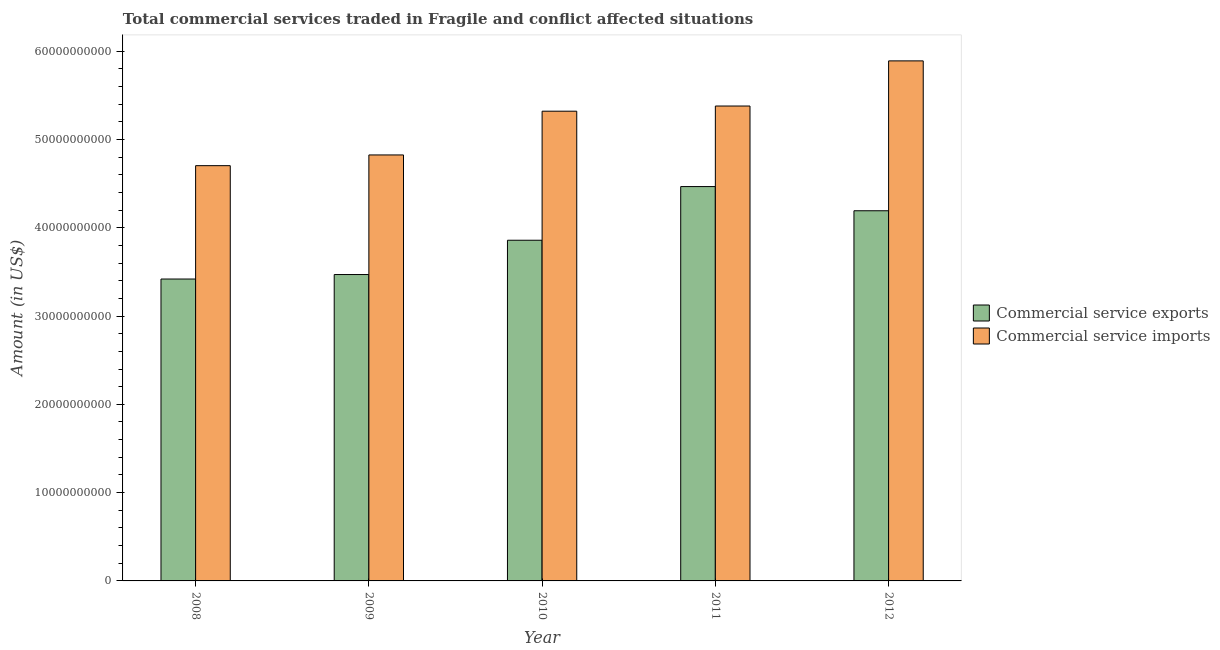How many different coloured bars are there?
Provide a succinct answer. 2. How many groups of bars are there?
Offer a terse response. 5. Are the number of bars per tick equal to the number of legend labels?
Offer a very short reply. Yes. Are the number of bars on each tick of the X-axis equal?
Keep it short and to the point. Yes. How many bars are there on the 3rd tick from the left?
Provide a short and direct response. 2. What is the label of the 3rd group of bars from the left?
Keep it short and to the point. 2010. What is the amount of commercial service exports in 2011?
Provide a succinct answer. 4.47e+1. Across all years, what is the maximum amount of commercial service imports?
Your answer should be compact. 5.89e+1. Across all years, what is the minimum amount of commercial service imports?
Provide a short and direct response. 4.70e+1. What is the total amount of commercial service imports in the graph?
Your answer should be compact. 2.61e+11. What is the difference between the amount of commercial service exports in 2010 and that in 2011?
Ensure brevity in your answer.  -6.08e+09. What is the difference between the amount of commercial service exports in 2012 and the amount of commercial service imports in 2008?
Your response must be concise. 7.73e+09. What is the average amount of commercial service imports per year?
Your response must be concise. 5.22e+1. What is the ratio of the amount of commercial service imports in 2011 to that in 2012?
Offer a terse response. 0.91. Is the difference between the amount of commercial service exports in 2009 and 2011 greater than the difference between the amount of commercial service imports in 2009 and 2011?
Make the answer very short. No. What is the difference between the highest and the second highest amount of commercial service imports?
Provide a succinct answer. 5.11e+09. What is the difference between the highest and the lowest amount of commercial service exports?
Offer a terse response. 1.05e+1. In how many years, is the amount of commercial service imports greater than the average amount of commercial service imports taken over all years?
Your answer should be compact. 3. Is the sum of the amount of commercial service exports in 2009 and 2012 greater than the maximum amount of commercial service imports across all years?
Your response must be concise. Yes. What does the 1st bar from the left in 2008 represents?
Your answer should be very brief. Commercial service exports. What does the 2nd bar from the right in 2011 represents?
Offer a terse response. Commercial service exports. Does the graph contain any zero values?
Your answer should be compact. No. Does the graph contain grids?
Keep it short and to the point. No. Where does the legend appear in the graph?
Your answer should be compact. Center right. How many legend labels are there?
Make the answer very short. 2. How are the legend labels stacked?
Offer a very short reply. Vertical. What is the title of the graph?
Make the answer very short. Total commercial services traded in Fragile and conflict affected situations. Does "Forest land" appear as one of the legend labels in the graph?
Your answer should be compact. No. What is the Amount (in US$) in Commercial service exports in 2008?
Ensure brevity in your answer.  3.42e+1. What is the Amount (in US$) of Commercial service imports in 2008?
Keep it short and to the point. 4.70e+1. What is the Amount (in US$) of Commercial service exports in 2009?
Make the answer very short. 3.47e+1. What is the Amount (in US$) of Commercial service imports in 2009?
Your answer should be very brief. 4.82e+1. What is the Amount (in US$) in Commercial service exports in 2010?
Your answer should be very brief. 3.86e+1. What is the Amount (in US$) in Commercial service imports in 2010?
Offer a terse response. 5.32e+1. What is the Amount (in US$) of Commercial service exports in 2011?
Give a very brief answer. 4.47e+1. What is the Amount (in US$) in Commercial service imports in 2011?
Make the answer very short. 5.38e+1. What is the Amount (in US$) in Commercial service exports in 2012?
Your answer should be very brief. 4.19e+1. What is the Amount (in US$) in Commercial service imports in 2012?
Provide a succinct answer. 5.89e+1. Across all years, what is the maximum Amount (in US$) in Commercial service exports?
Your answer should be very brief. 4.47e+1. Across all years, what is the maximum Amount (in US$) of Commercial service imports?
Offer a terse response. 5.89e+1. Across all years, what is the minimum Amount (in US$) of Commercial service exports?
Your answer should be very brief. 3.42e+1. Across all years, what is the minimum Amount (in US$) of Commercial service imports?
Offer a very short reply. 4.70e+1. What is the total Amount (in US$) of Commercial service exports in the graph?
Offer a very short reply. 1.94e+11. What is the total Amount (in US$) in Commercial service imports in the graph?
Offer a terse response. 2.61e+11. What is the difference between the Amount (in US$) in Commercial service exports in 2008 and that in 2009?
Offer a very short reply. -5.09e+08. What is the difference between the Amount (in US$) of Commercial service imports in 2008 and that in 2009?
Give a very brief answer. -1.21e+09. What is the difference between the Amount (in US$) in Commercial service exports in 2008 and that in 2010?
Make the answer very short. -4.39e+09. What is the difference between the Amount (in US$) of Commercial service imports in 2008 and that in 2010?
Your response must be concise. -6.17e+09. What is the difference between the Amount (in US$) in Commercial service exports in 2008 and that in 2011?
Make the answer very short. -1.05e+1. What is the difference between the Amount (in US$) in Commercial service imports in 2008 and that in 2011?
Provide a succinct answer. -6.76e+09. What is the difference between the Amount (in US$) in Commercial service exports in 2008 and that in 2012?
Your answer should be very brief. -7.73e+09. What is the difference between the Amount (in US$) of Commercial service imports in 2008 and that in 2012?
Keep it short and to the point. -1.19e+1. What is the difference between the Amount (in US$) of Commercial service exports in 2009 and that in 2010?
Keep it short and to the point. -3.88e+09. What is the difference between the Amount (in US$) of Commercial service imports in 2009 and that in 2010?
Your response must be concise. -4.95e+09. What is the difference between the Amount (in US$) in Commercial service exports in 2009 and that in 2011?
Provide a short and direct response. -9.96e+09. What is the difference between the Amount (in US$) in Commercial service imports in 2009 and that in 2011?
Give a very brief answer. -5.54e+09. What is the difference between the Amount (in US$) of Commercial service exports in 2009 and that in 2012?
Make the answer very short. -7.22e+09. What is the difference between the Amount (in US$) in Commercial service imports in 2009 and that in 2012?
Provide a succinct answer. -1.07e+1. What is the difference between the Amount (in US$) in Commercial service exports in 2010 and that in 2011?
Offer a very short reply. -6.08e+09. What is the difference between the Amount (in US$) in Commercial service imports in 2010 and that in 2011?
Ensure brevity in your answer.  -5.87e+08. What is the difference between the Amount (in US$) of Commercial service exports in 2010 and that in 2012?
Offer a very short reply. -3.34e+09. What is the difference between the Amount (in US$) in Commercial service imports in 2010 and that in 2012?
Your answer should be very brief. -5.70e+09. What is the difference between the Amount (in US$) of Commercial service exports in 2011 and that in 2012?
Keep it short and to the point. 2.74e+09. What is the difference between the Amount (in US$) of Commercial service imports in 2011 and that in 2012?
Offer a very short reply. -5.11e+09. What is the difference between the Amount (in US$) of Commercial service exports in 2008 and the Amount (in US$) of Commercial service imports in 2009?
Offer a terse response. -1.41e+1. What is the difference between the Amount (in US$) of Commercial service exports in 2008 and the Amount (in US$) of Commercial service imports in 2010?
Offer a terse response. -1.90e+1. What is the difference between the Amount (in US$) of Commercial service exports in 2008 and the Amount (in US$) of Commercial service imports in 2011?
Provide a short and direct response. -1.96e+1. What is the difference between the Amount (in US$) in Commercial service exports in 2008 and the Amount (in US$) in Commercial service imports in 2012?
Make the answer very short. -2.47e+1. What is the difference between the Amount (in US$) of Commercial service exports in 2009 and the Amount (in US$) of Commercial service imports in 2010?
Provide a short and direct response. -1.85e+1. What is the difference between the Amount (in US$) of Commercial service exports in 2009 and the Amount (in US$) of Commercial service imports in 2011?
Offer a very short reply. -1.91e+1. What is the difference between the Amount (in US$) in Commercial service exports in 2009 and the Amount (in US$) in Commercial service imports in 2012?
Your response must be concise. -2.42e+1. What is the difference between the Amount (in US$) of Commercial service exports in 2010 and the Amount (in US$) of Commercial service imports in 2011?
Keep it short and to the point. -1.52e+1. What is the difference between the Amount (in US$) in Commercial service exports in 2010 and the Amount (in US$) in Commercial service imports in 2012?
Ensure brevity in your answer.  -2.03e+1. What is the difference between the Amount (in US$) of Commercial service exports in 2011 and the Amount (in US$) of Commercial service imports in 2012?
Ensure brevity in your answer.  -1.42e+1. What is the average Amount (in US$) of Commercial service exports per year?
Keep it short and to the point. 3.88e+1. What is the average Amount (in US$) of Commercial service imports per year?
Make the answer very short. 5.22e+1. In the year 2008, what is the difference between the Amount (in US$) in Commercial service exports and Amount (in US$) in Commercial service imports?
Keep it short and to the point. -1.28e+1. In the year 2009, what is the difference between the Amount (in US$) of Commercial service exports and Amount (in US$) of Commercial service imports?
Give a very brief answer. -1.35e+1. In the year 2010, what is the difference between the Amount (in US$) in Commercial service exports and Amount (in US$) in Commercial service imports?
Your answer should be very brief. -1.46e+1. In the year 2011, what is the difference between the Amount (in US$) of Commercial service exports and Amount (in US$) of Commercial service imports?
Ensure brevity in your answer.  -9.12e+09. In the year 2012, what is the difference between the Amount (in US$) of Commercial service exports and Amount (in US$) of Commercial service imports?
Provide a short and direct response. -1.70e+1. What is the ratio of the Amount (in US$) in Commercial service exports in 2008 to that in 2009?
Offer a terse response. 0.99. What is the ratio of the Amount (in US$) in Commercial service imports in 2008 to that in 2009?
Provide a short and direct response. 0.97. What is the ratio of the Amount (in US$) in Commercial service exports in 2008 to that in 2010?
Offer a very short reply. 0.89. What is the ratio of the Amount (in US$) of Commercial service imports in 2008 to that in 2010?
Your response must be concise. 0.88. What is the ratio of the Amount (in US$) in Commercial service exports in 2008 to that in 2011?
Provide a succinct answer. 0.77. What is the ratio of the Amount (in US$) in Commercial service imports in 2008 to that in 2011?
Your answer should be very brief. 0.87. What is the ratio of the Amount (in US$) in Commercial service exports in 2008 to that in 2012?
Your answer should be compact. 0.82. What is the ratio of the Amount (in US$) in Commercial service imports in 2008 to that in 2012?
Keep it short and to the point. 0.8. What is the ratio of the Amount (in US$) in Commercial service exports in 2009 to that in 2010?
Your answer should be compact. 0.9. What is the ratio of the Amount (in US$) in Commercial service imports in 2009 to that in 2010?
Your answer should be compact. 0.91. What is the ratio of the Amount (in US$) in Commercial service exports in 2009 to that in 2011?
Make the answer very short. 0.78. What is the ratio of the Amount (in US$) of Commercial service imports in 2009 to that in 2011?
Offer a very short reply. 0.9. What is the ratio of the Amount (in US$) in Commercial service exports in 2009 to that in 2012?
Offer a very short reply. 0.83. What is the ratio of the Amount (in US$) in Commercial service imports in 2009 to that in 2012?
Make the answer very short. 0.82. What is the ratio of the Amount (in US$) of Commercial service exports in 2010 to that in 2011?
Your answer should be very brief. 0.86. What is the ratio of the Amount (in US$) of Commercial service exports in 2010 to that in 2012?
Offer a very short reply. 0.92. What is the ratio of the Amount (in US$) in Commercial service imports in 2010 to that in 2012?
Make the answer very short. 0.9. What is the ratio of the Amount (in US$) in Commercial service exports in 2011 to that in 2012?
Your response must be concise. 1.07. What is the ratio of the Amount (in US$) in Commercial service imports in 2011 to that in 2012?
Provide a succinct answer. 0.91. What is the difference between the highest and the second highest Amount (in US$) in Commercial service exports?
Your response must be concise. 2.74e+09. What is the difference between the highest and the second highest Amount (in US$) in Commercial service imports?
Your response must be concise. 5.11e+09. What is the difference between the highest and the lowest Amount (in US$) in Commercial service exports?
Your response must be concise. 1.05e+1. What is the difference between the highest and the lowest Amount (in US$) in Commercial service imports?
Your answer should be compact. 1.19e+1. 